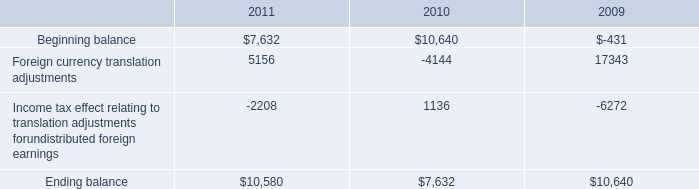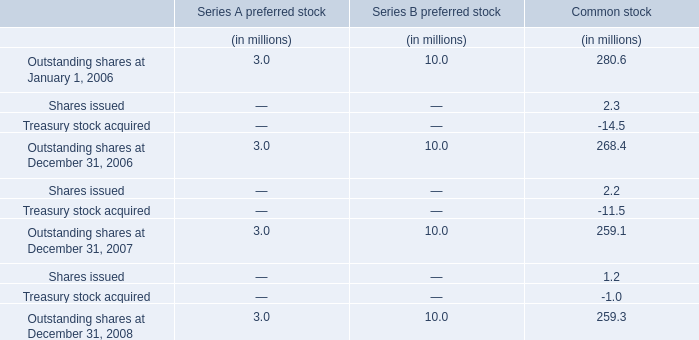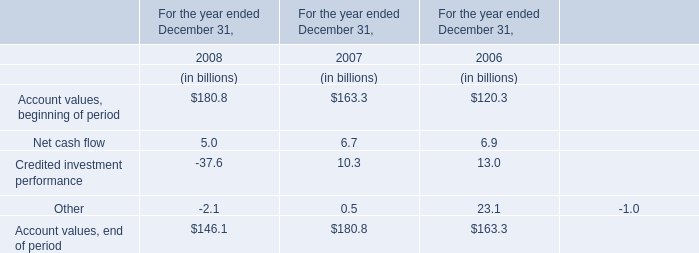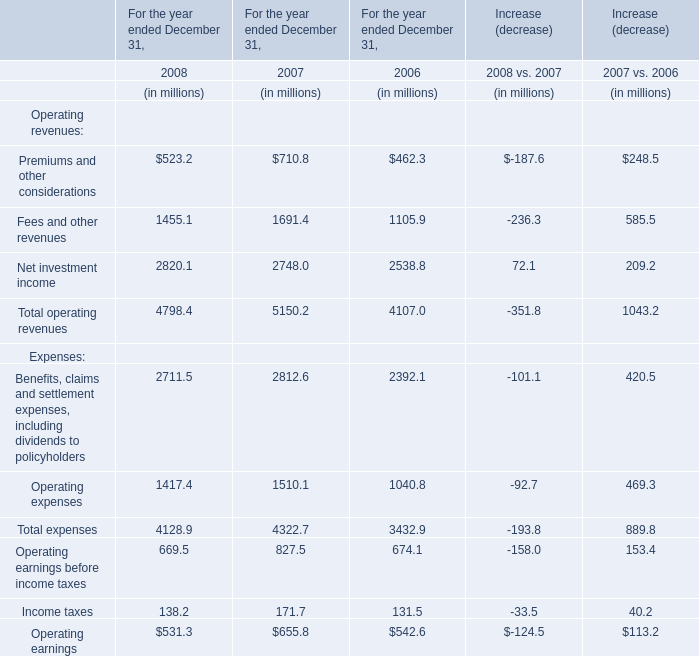What is the total value of Account values, beginning of periodNet cash flowCredited investment performanceOther in 2008/ (in billion) 
Computations: (((180.8 + 5) - 37.6) - 2.1)
Answer: 146.1. 